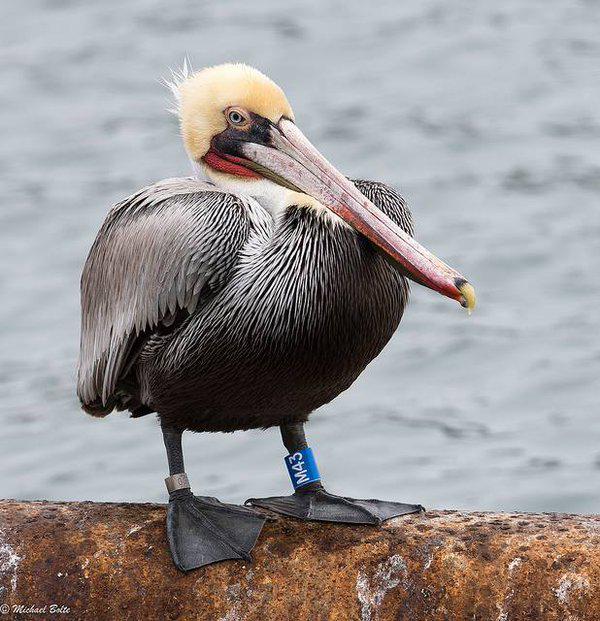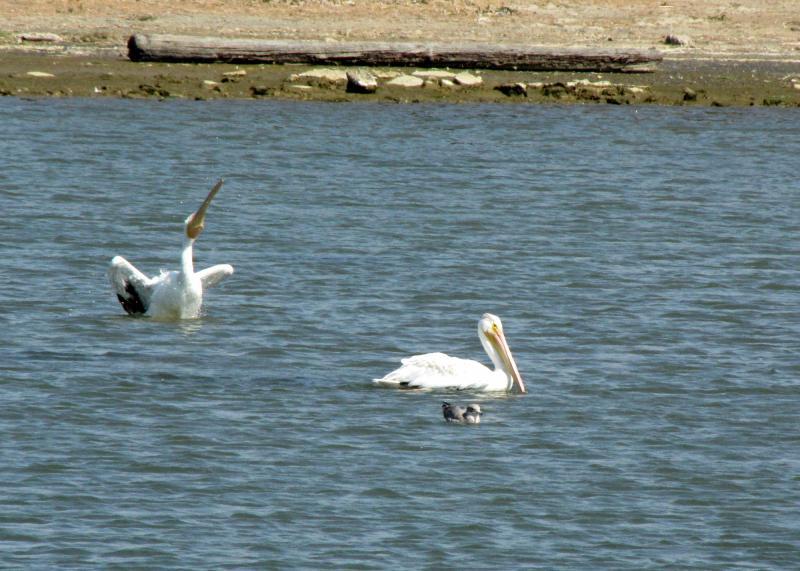The first image is the image on the left, the second image is the image on the right. Evaluate the accuracy of this statement regarding the images: "One lone pelican is out of the water in one of the images, while all of the pelicans are swimming in the other image.". Is it true? Answer yes or no. Yes. 